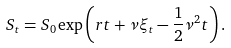<formula> <loc_0><loc_0><loc_500><loc_500>S _ { t } = S _ { 0 } \exp \left ( r t + \nu \xi _ { t } - \frac { 1 } { 2 } \nu ^ { 2 } t \right ) .</formula> 